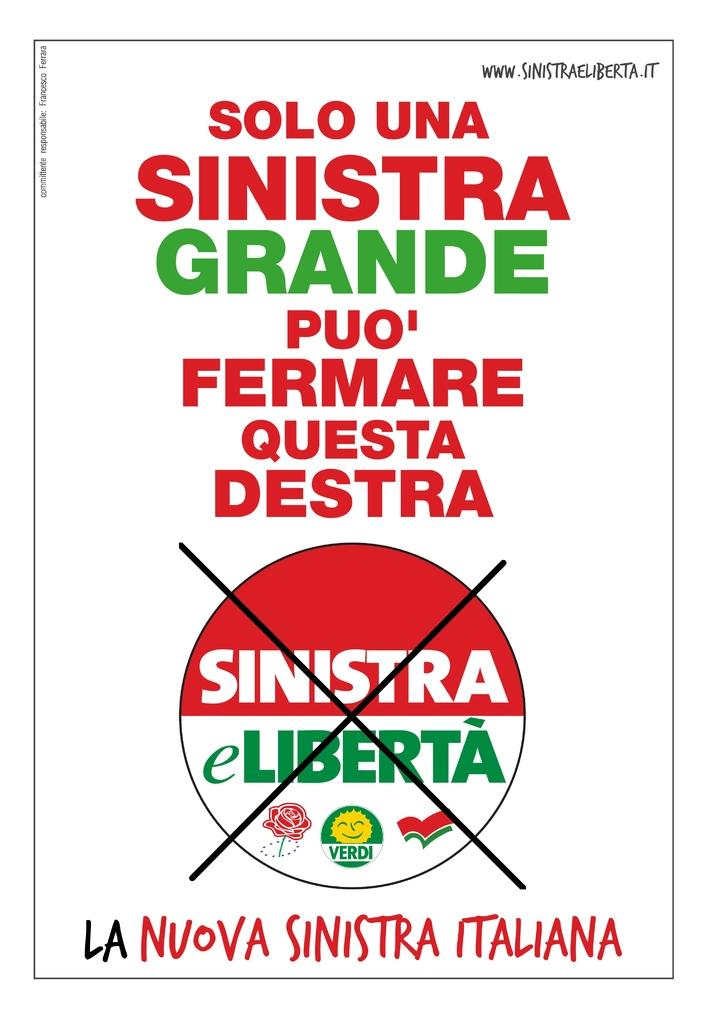<image>
Share a concise interpretation of the image provided. A poster that says Solo Una Sinistra Grande Puo' on it. 